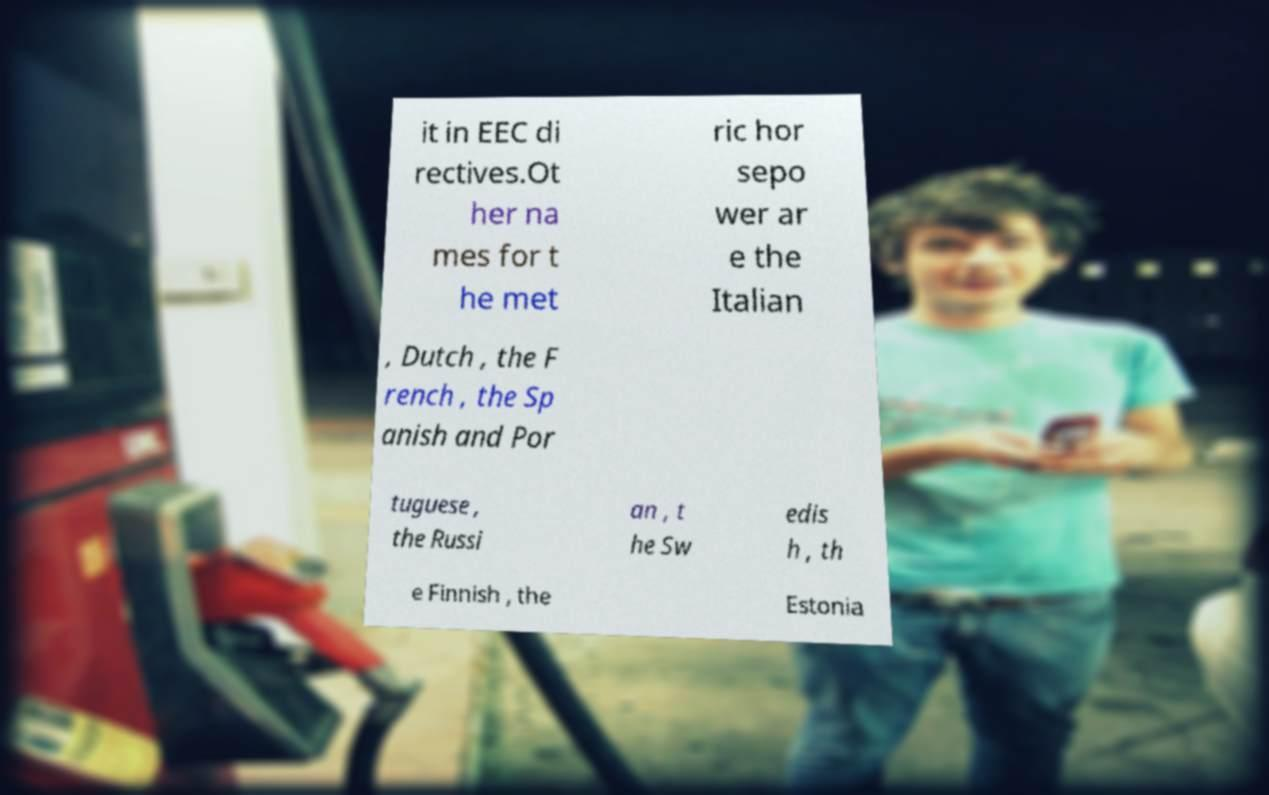Please identify and transcribe the text found in this image. it in EEC di rectives.Ot her na mes for t he met ric hor sepo wer ar e the Italian , Dutch , the F rench , the Sp anish and Por tuguese , the Russi an , t he Sw edis h , th e Finnish , the Estonia 